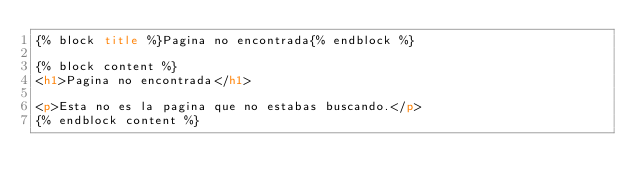Convert code to text. <code><loc_0><loc_0><loc_500><loc_500><_HTML_>{% block title %}Pagina no encontrada{% endblock %}

{% block content %}
<h1>Pagina no encontrada</h1>

<p>Esta no es la pagina que no estabas buscando.</p>
{% endblock content %}
</code> 